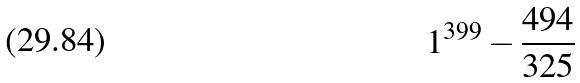Convert formula to latex. <formula><loc_0><loc_0><loc_500><loc_500>1 ^ { 3 9 9 } - \frac { 4 9 4 } { 3 2 5 }</formula> 